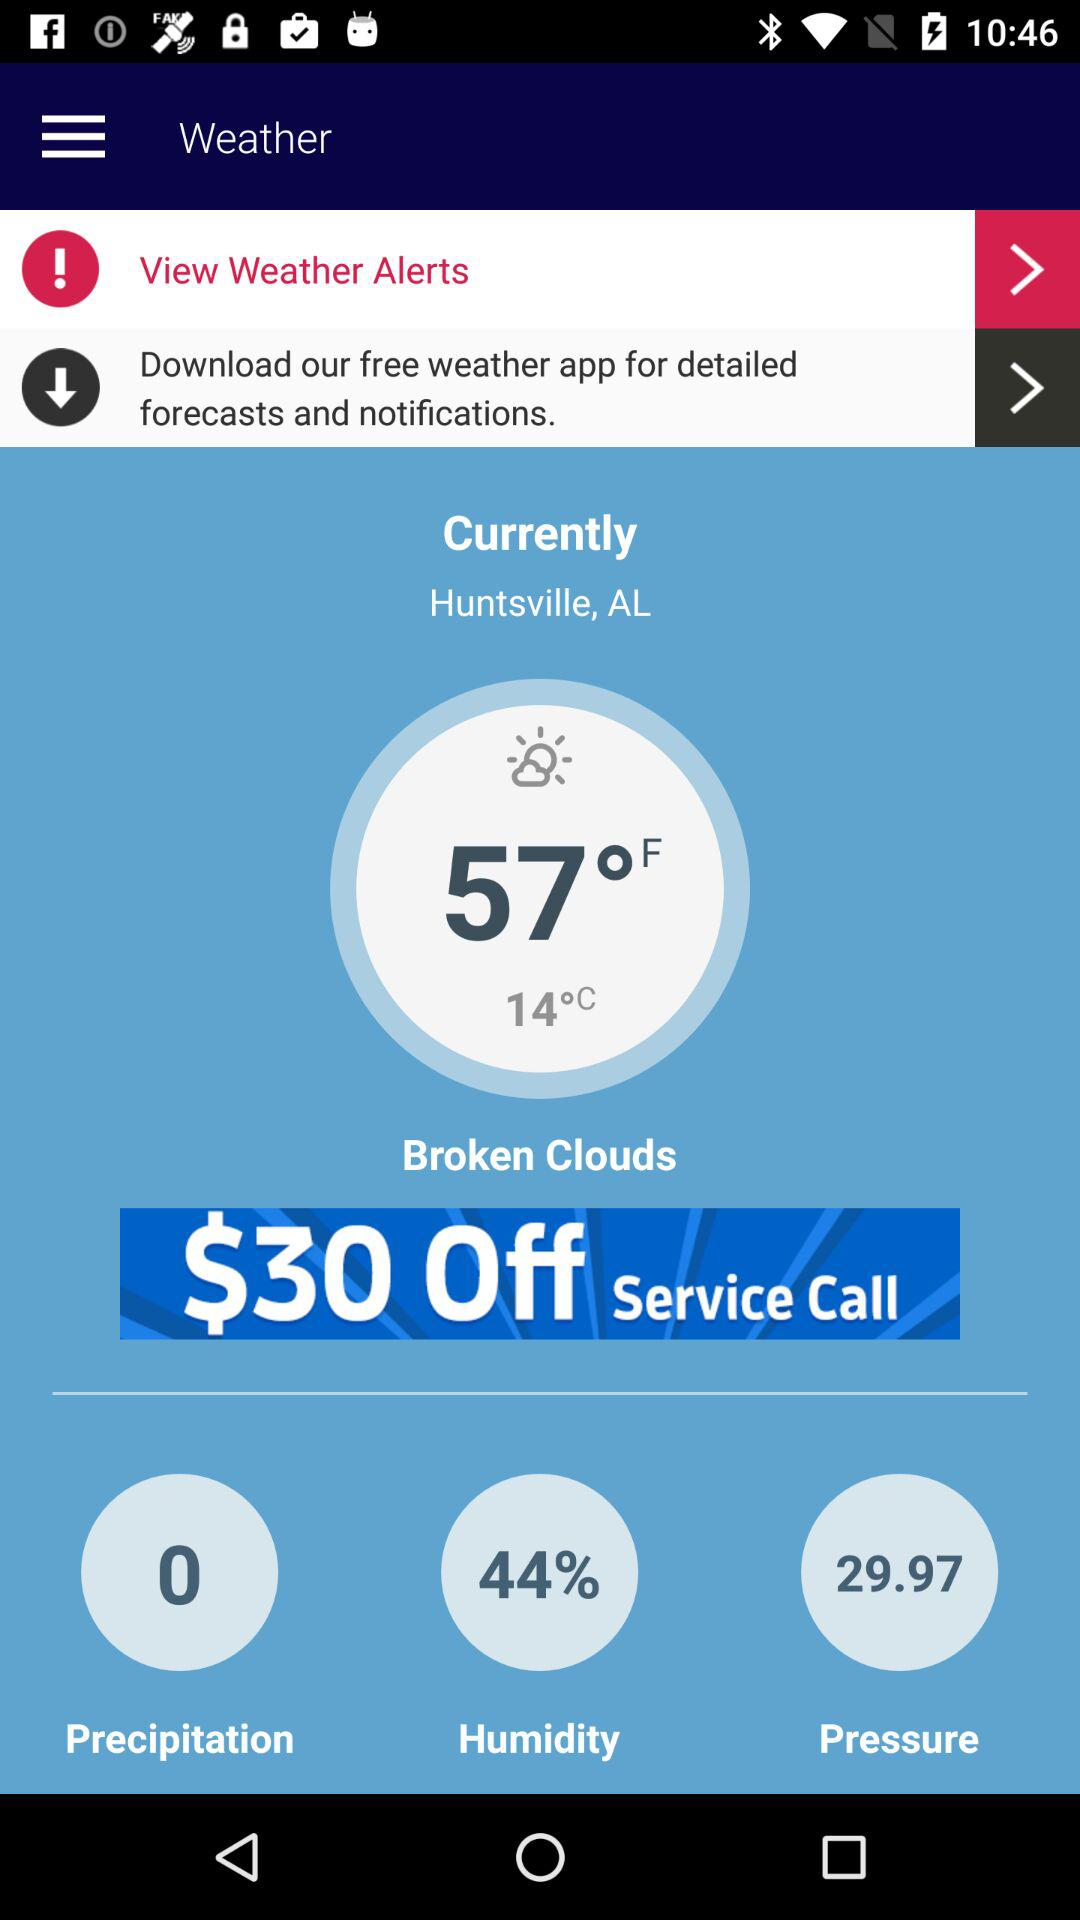What is the percentage of humidity? The percentage of humidity is 44. 